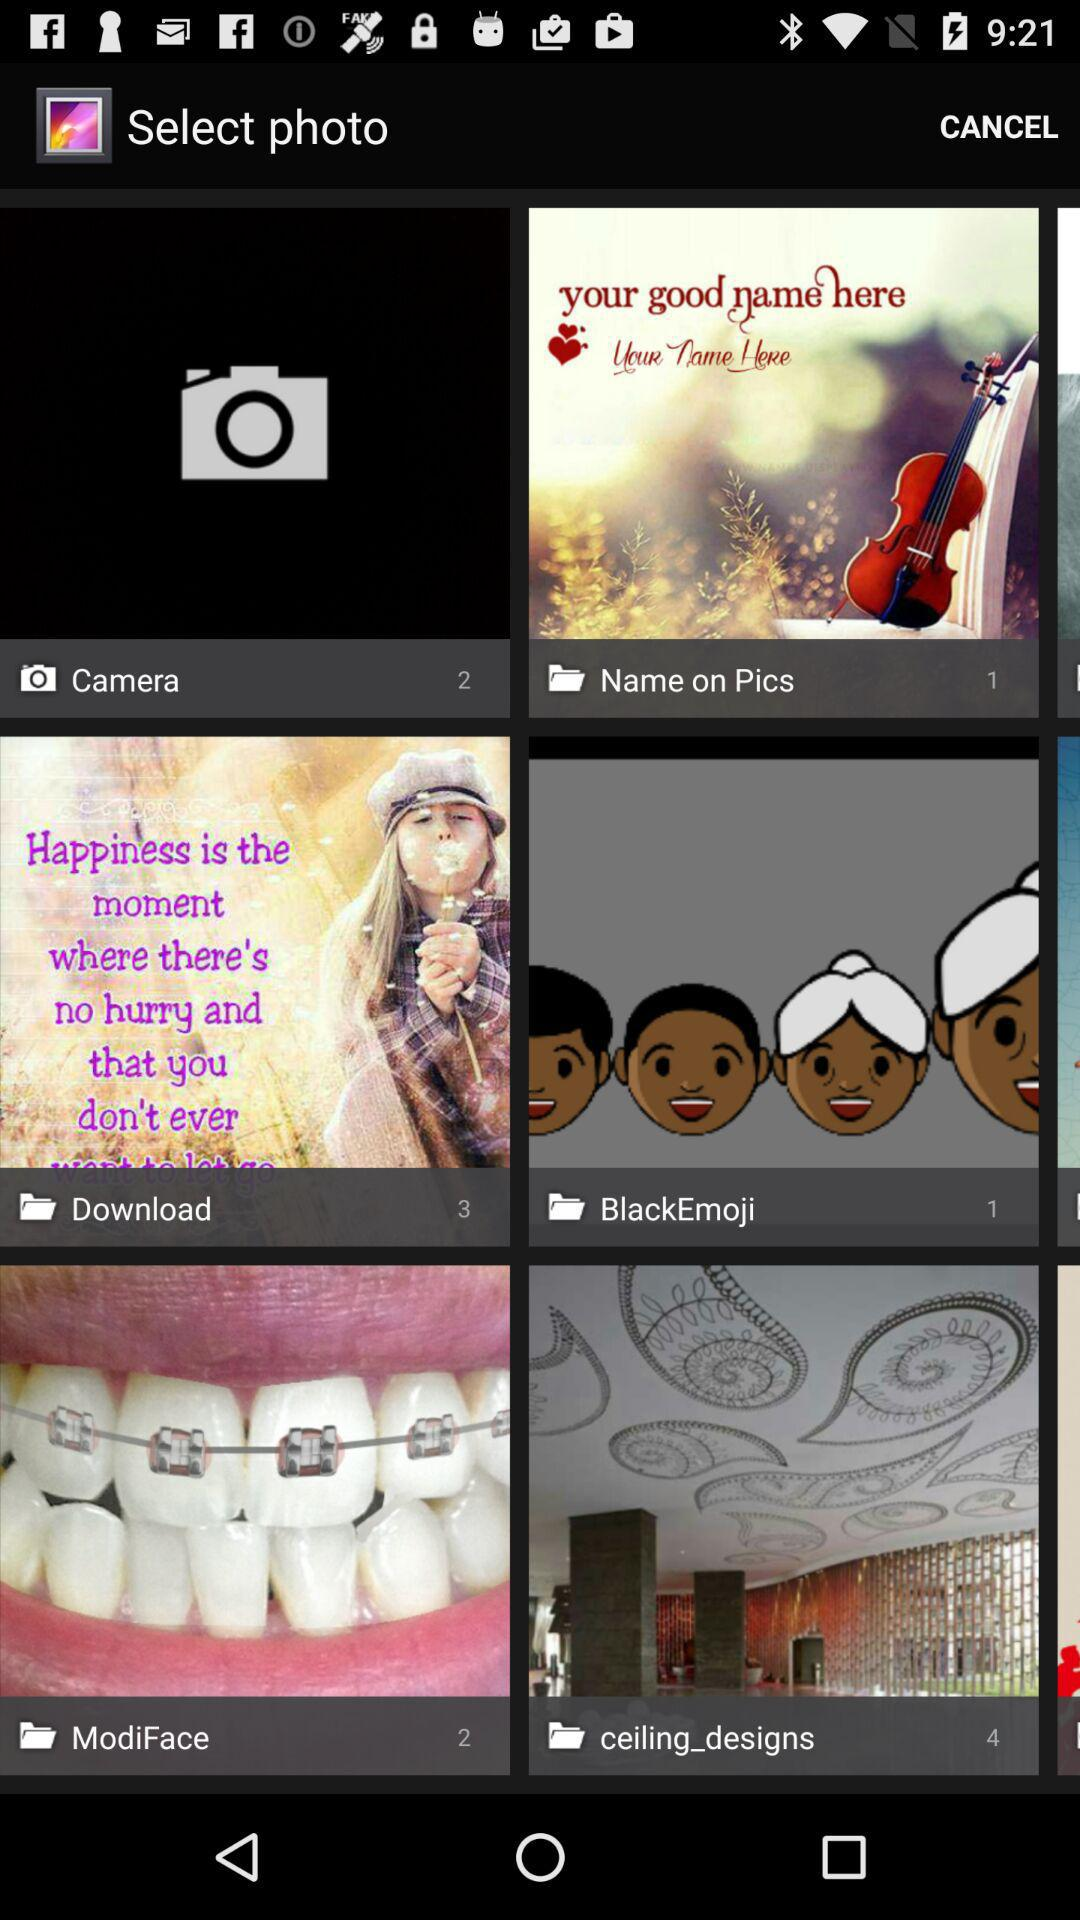What is the name of the application?
When the provided information is insufficient, respond with <no answer>. <no answer> 